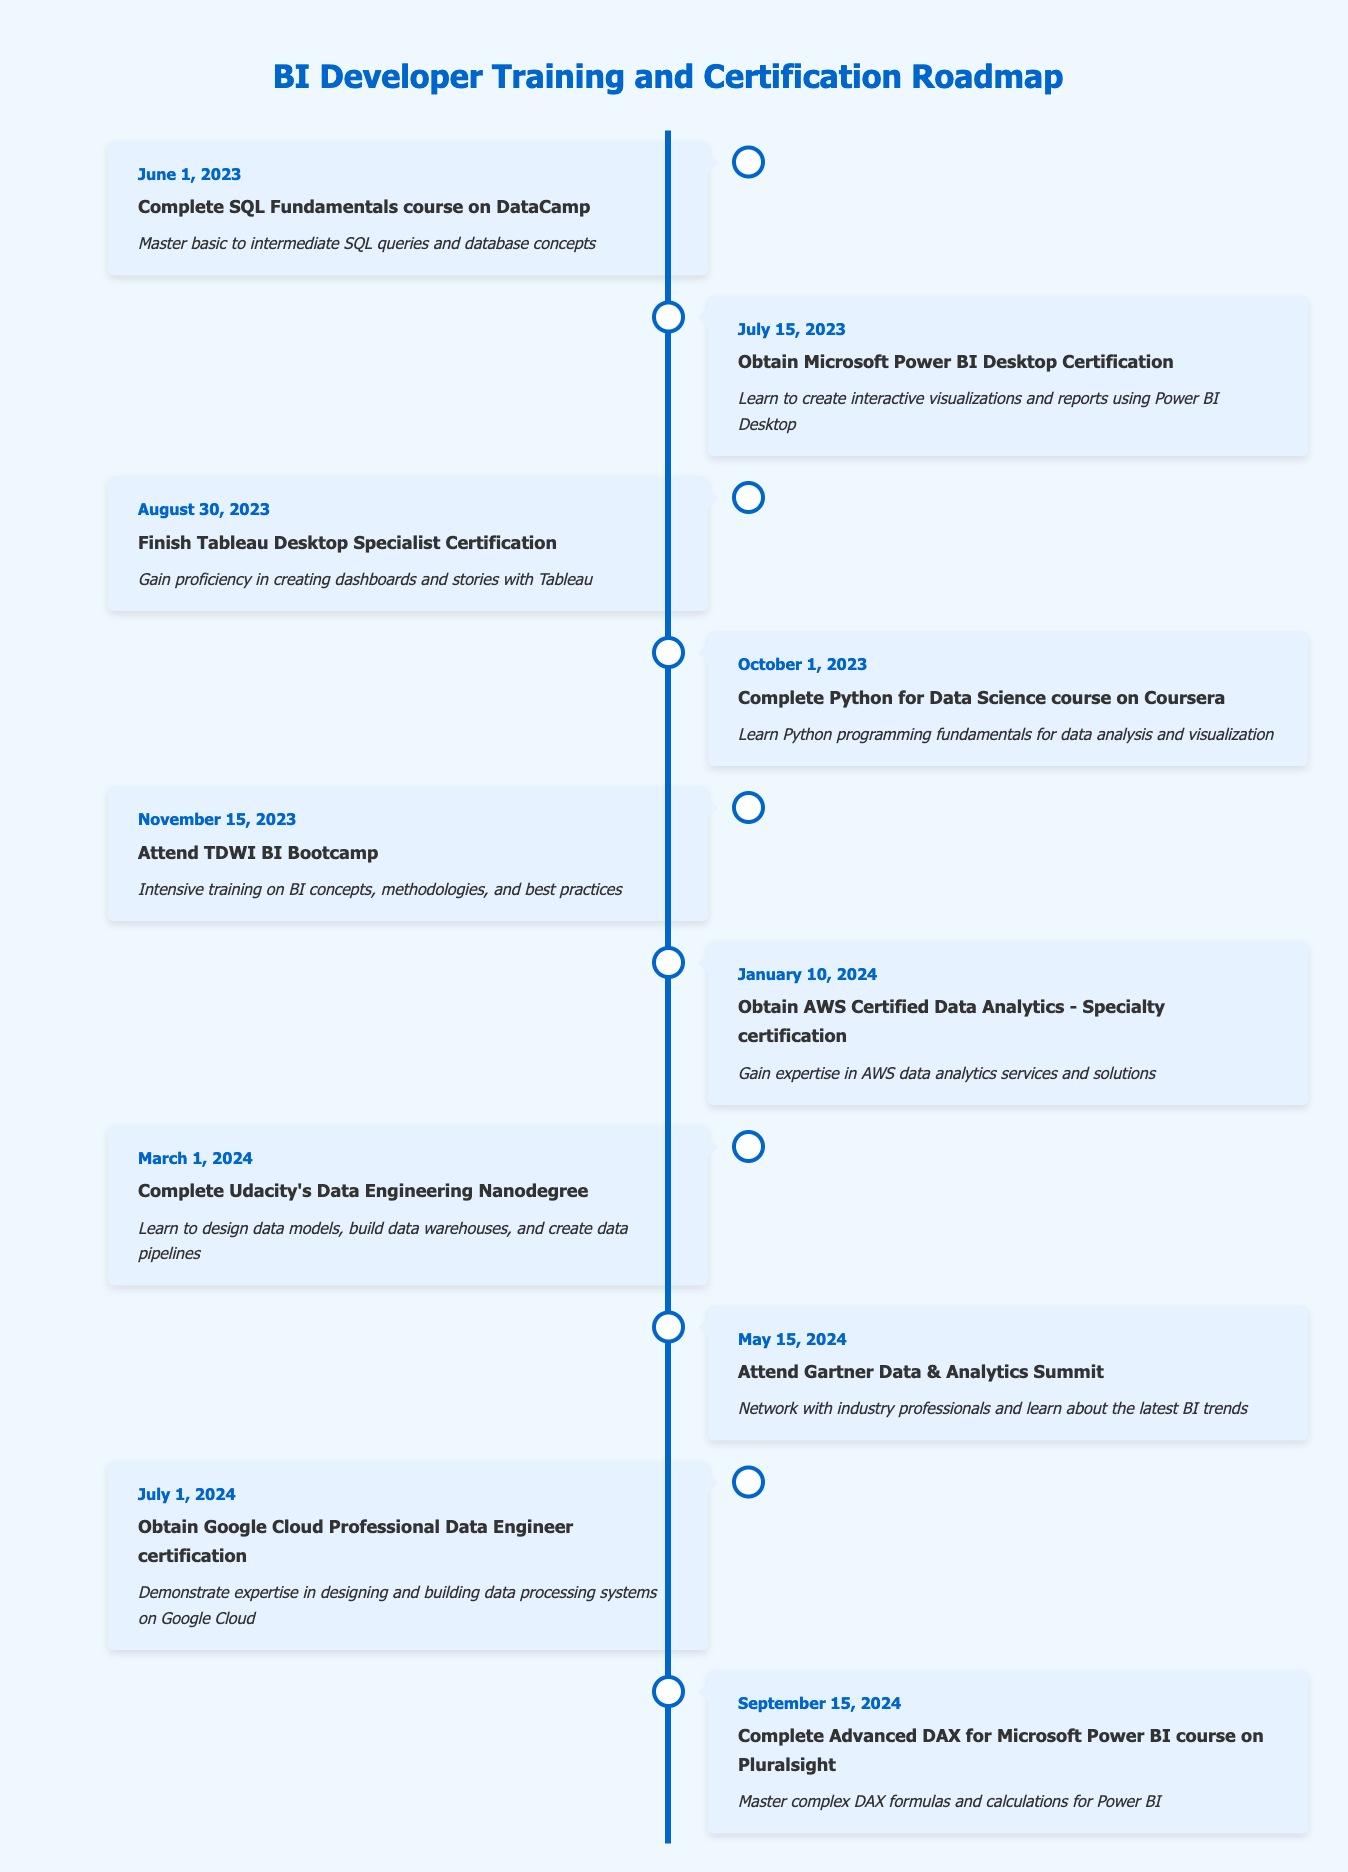What is the first event in the timeline? The first event listed is "Complete SQL Fundamentals course on DataCamp," which occurs on June 1, 2023.
Answer: Complete SQL Fundamentals course on DataCamp How many certification events are in the timeline? There are 5 certification events, which are the Microsoft Power BI Desktop Certification, Tableau Desktop Specialist Certification, AWS Certified Data Analytics - Specialty certification, Google Cloud Professional Data Engineer certification, and Advanced DAX for Microsoft Power BI course.
Answer: 5 When does the individual attend the TDWI BI Bootcamp? The TDWI BI Bootcamp is scheduled for November 15, 2023, as noted in the timeline.
Answer: November 15, 2023 Is there an event related to Python training? Yes, there is an event titled "Complete Python for Data Science course on Coursera," which takes place on October 1, 2023.
Answer: Yes How many months are there between the completion of the SQL Fundamentals course and the completion of the Python for Data Science course? The SQL Fundamentals course is completed on June 1, 2023, and the Python for Data Science course is completed on October 1, 2023. The duration between the two dates is 4 months.
Answer: 4 months Which event is the last one listed in the timeline and when does it take place? The last event in the timeline is "Complete Advanced DAX for Microsoft Power BI course on Pluralsight," which takes place on September 15, 2024.
Answer: Complete Advanced DAX for Microsoft Power BI course on Pluralsight, September 15, 2024 What types of skills are primarily focused on in the training events of this timeline? The training events primarily focus on skills related to SQL, Power BI, Tableau, Python, data analytics in the cloud, and data engineering methodologies.
Answer: SQL, BI tools, Python, Cloud analytics, Data engineering How many total events take place before the year 2024? There are 5 events listed that take place in 2023, prior to the year 2024, including the SQL course, Power BI certification, Tableau certification, Python course, and TDWI Bootcamp.
Answer: 5 